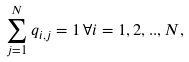<formula> <loc_0><loc_0><loc_500><loc_500>\sum _ { j = 1 } ^ { N } q _ { i , j } = 1 \, \forall i = 1 , 2 , . . , N ,</formula> 